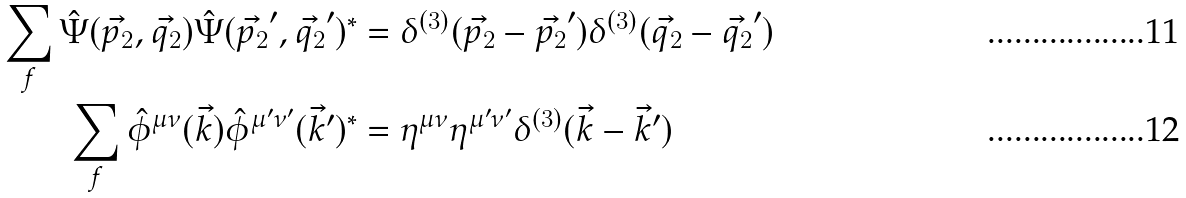<formula> <loc_0><loc_0><loc_500><loc_500>\sum _ { f } \hat { \Psi } ( \vec { p _ { 2 } } , \vec { q _ { 2 } } ) \hat { \Psi } ( \vec { p _ { 2 } } ^ { \prime } , \vec { q _ { 2 } } ^ { \prime } ) ^ { \ast } & = \delta ^ { ( 3 ) } ( \vec { p _ { 2 } } - \vec { p _ { 2 } } ^ { \prime } ) \delta ^ { ( 3 ) } ( \vec { q _ { 2 } } - \vec { q _ { 2 } } ^ { \prime } ) \\ \sum _ { f } \hat { \phi } ^ { \mu \nu } ( \vec { k } ) \hat { \phi } ^ { \mu ^ { \prime } \nu ^ { \prime } } ( \vec { k } ^ { \prime } ) ^ { \ast } & = \eta ^ { \mu \nu } \eta ^ { \mu ^ { \prime } \nu ^ { \prime } } \delta ^ { ( 3 ) } ( \vec { k } - \vec { k } ^ { \prime } )</formula> 